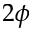Convert formula to latex. <formula><loc_0><loc_0><loc_500><loc_500>2 \phi</formula> 